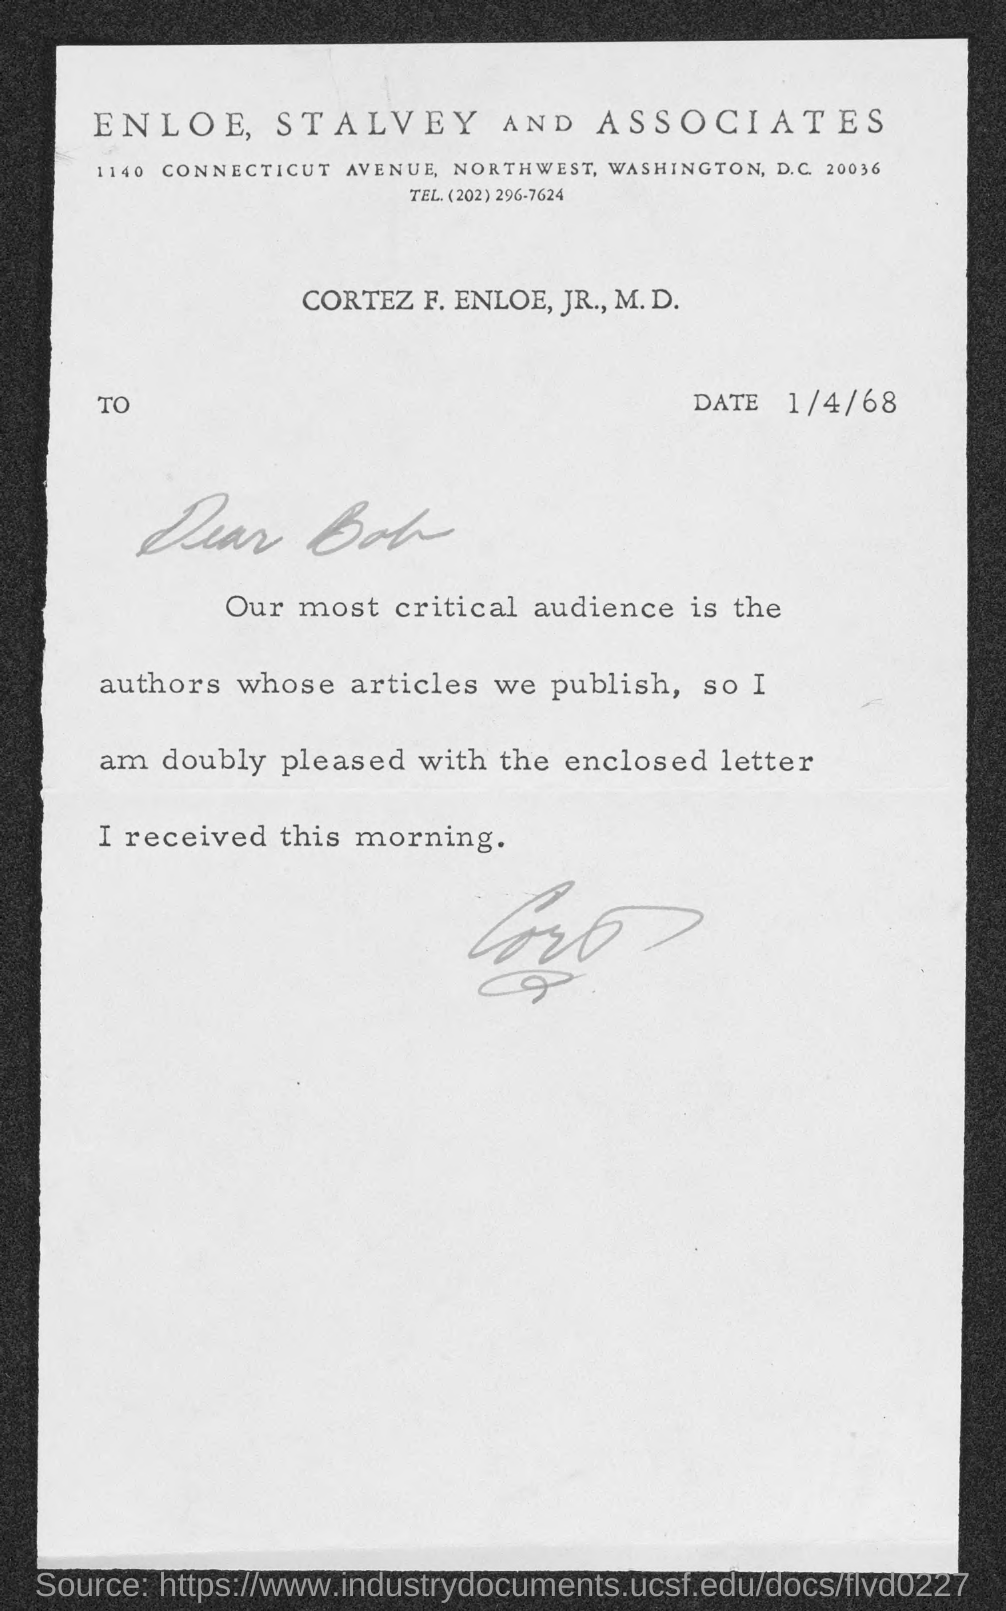List a handful of essential elements in this visual. This letter is addressed to Bob. The telephone number of Enloe, Stalvey and Associates is (202)296-7624. On what date was the letter dated? The letter is dated on April 1, 1968. 